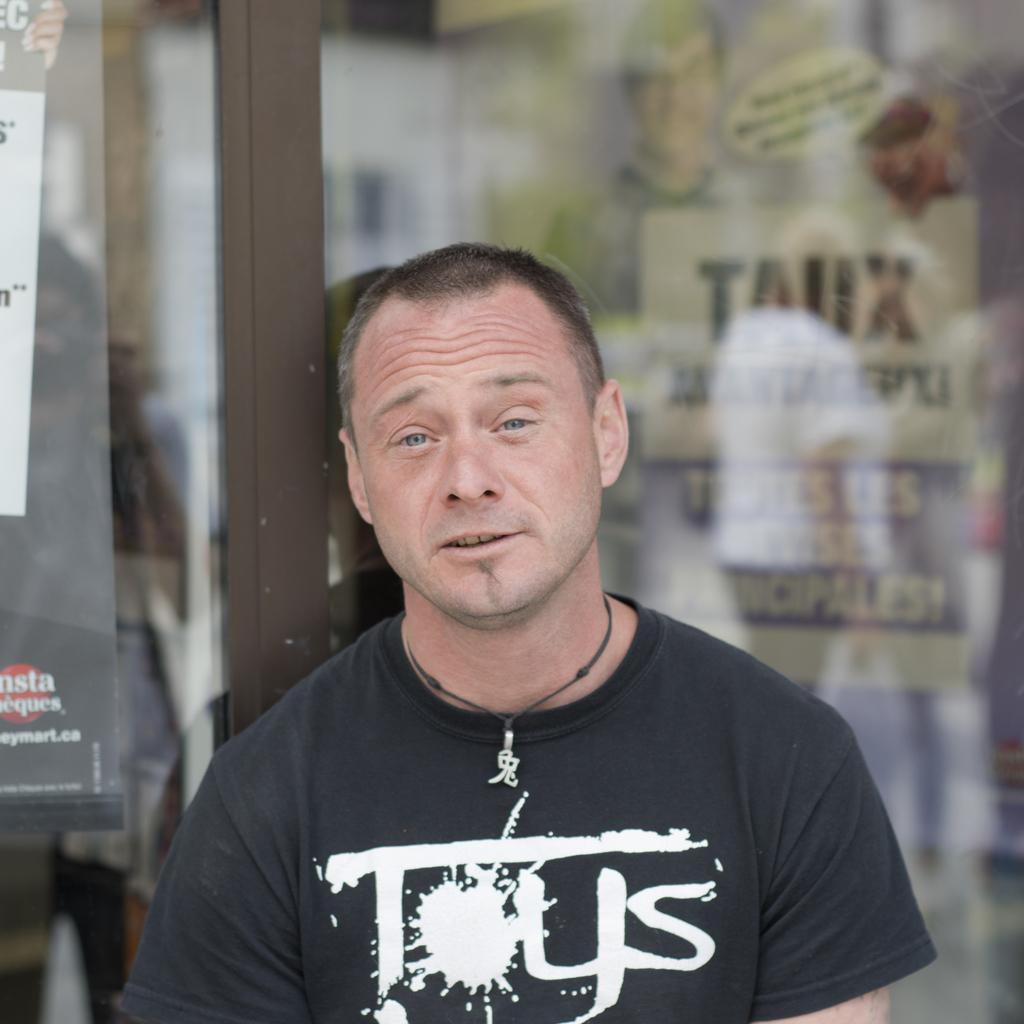In one or two sentences, can you explain what this image depicts? In this image we can see a person standing in front of a glass door. In the background, we can see some posters with some pictures and text. 